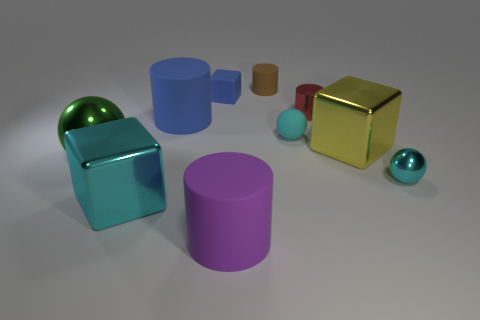Subtract all big blocks. How many blocks are left? 1 Subtract all green balls. How many balls are left? 2 Subtract all blocks. How many objects are left? 7 Subtract 2 cylinders. How many cylinders are left? 2 Subtract all green spheres. Subtract all gray blocks. How many spheres are left? 2 Subtract all red balls. How many red cylinders are left? 1 Subtract all large blue cylinders. Subtract all cyan blocks. How many objects are left? 8 Add 3 big purple objects. How many big purple objects are left? 4 Add 2 big cylinders. How many big cylinders exist? 4 Subtract 0 purple blocks. How many objects are left? 10 